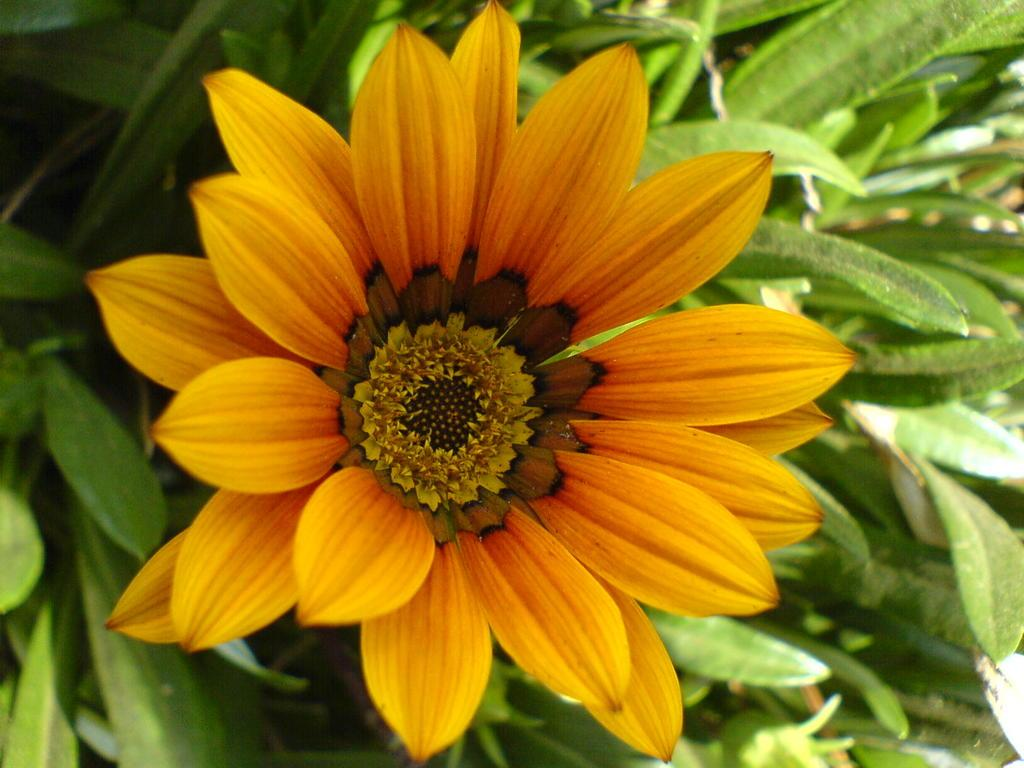What is the main subject of the image? The main subject of the image is a flower. Where is the flower located? The flower is on a plant. What is the color of the flower? The flower is orange in color. How many apples are hanging from the flower in the image? There are no apples present in the image; it features a flower on a plant. Can you tell me how many books are visible in the library in the image? There is no library present in the image, as it features a flower on a plant. 